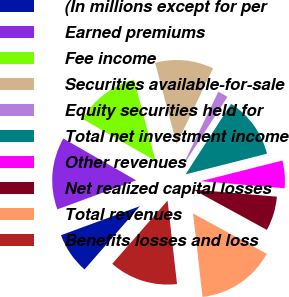Convert chart to OTSL. <chart><loc_0><loc_0><loc_500><loc_500><pie_chart><fcel>(In millions except for per<fcel>Earned premiums<fcel>Fee income<fcel>Securities available-for-sale<fcel>Equity securities held for<fcel>Total net investment income<fcel>Other revenues<fcel>Net realized capital losses<fcel>Total revenues<fcel>Benefits losses and loss<nl><fcel>7.95%<fcel>13.91%<fcel>12.58%<fcel>11.26%<fcel>1.99%<fcel>11.92%<fcel>5.3%<fcel>6.62%<fcel>15.23%<fcel>13.24%<nl></chart> 